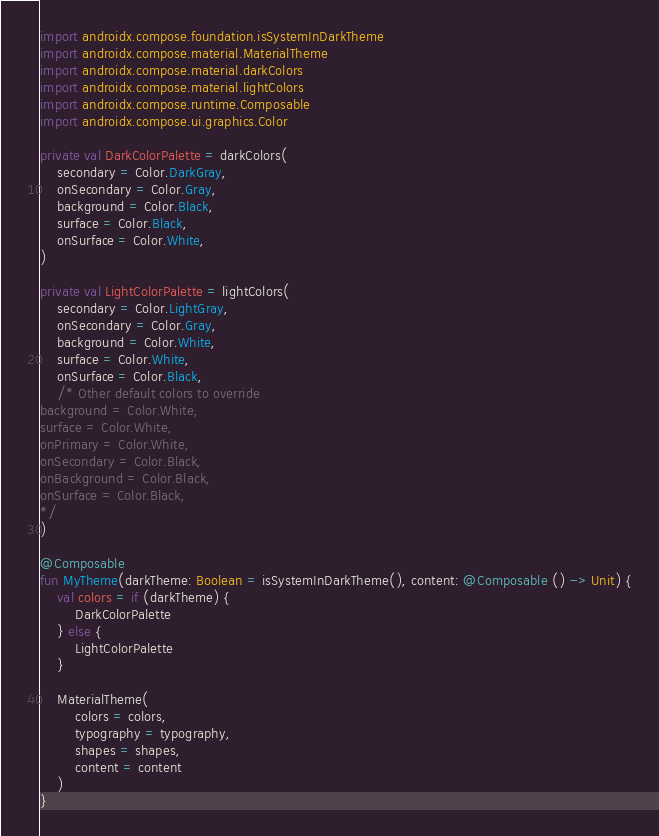Convert code to text. <code><loc_0><loc_0><loc_500><loc_500><_Kotlin_>
import androidx.compose.foundation.isSystemInDarkTheme
import androidx.compose.material.MaterialTheme
import androidx.compose.material.darkColors
import androidx.compose.material.lightColors
import androidx.compose.runtime.Composable
import androidx.compose.ui.graphics.Color

private val DarkColorPalette = darkColors(
    secondary = Color.DarkGray,
    onSecondary = Color.Gray,
    background = Color.Black,
    surface = Color.Black,
    onSurface = Color.White,
)

private val LightColorPalette = lightColors(
    secondary = Color.LightGray,
    onSecondary = Color.Gray,
    background = Color.White,
    surface = Color.White,
    onSurface = Color.Black,
    /* Other default colors to override
background = Color.White,
surface = Color.White,
onPrimary = Color.White,
onSecondary = Color.Black,
onBackground = Color.Black,
onSurface = Color.Black,
*/
)

@Composable
fun MyTheme(darkTheme: Boolean = isSystemInDarkTheme(), content: @Composable () -> Unit) {
    val colors = if (darkTheme) {
        DarkColorPalette
    } else {
        LightColorPalette
    }

    MaterialTheme(
        colors = colors,
        typography = typography,
        shapes = shapes,
        content = content
    )
}
</code> 